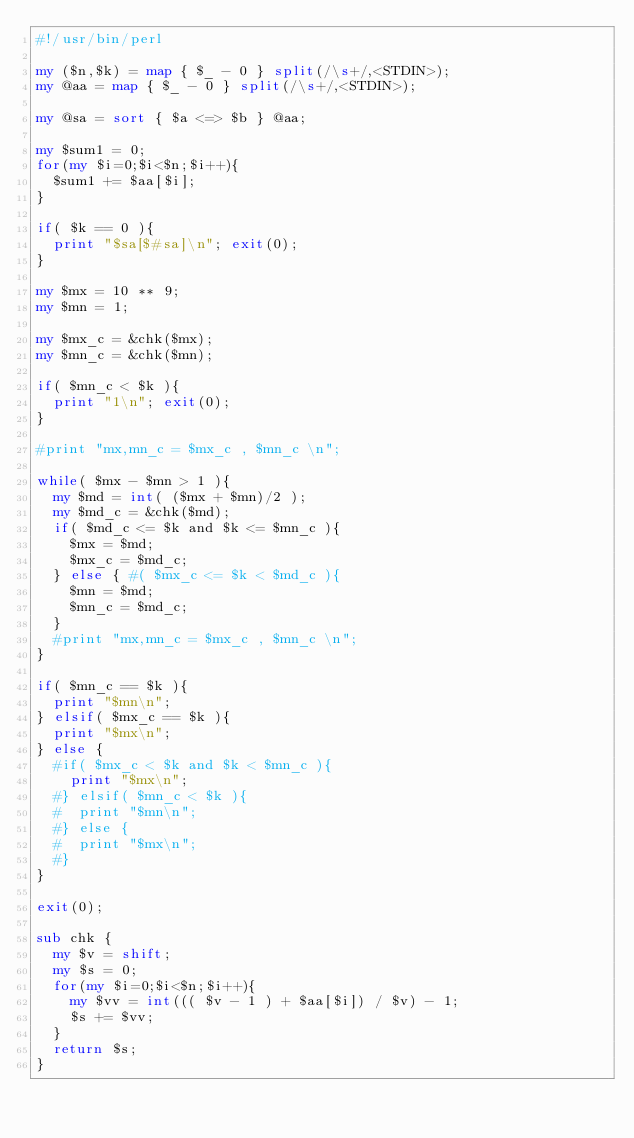<code> <loc_0><loc_0><loc_500><loc_500><_Perl_>#!/usr/bin/perl

my ($n,$k) = map { $_ - 0 } split(/\s+/,<STDIN>);
my @aa = map { $_ - 0 } split(/\s+/,<STDIN>);

my @sa = sort { $a <=> $b } @aa;

my $sum1 = 0;
for(my $i=0;$i<$n;$i++){
  $sum1 += $aa[$i];
}

if( $k == 0 ){
  print "$sa[$#sa]\n"; exit(0);
}

my $mx = 10 ** 9;
my $mn = 1;

my $mx_c = &chk($mx);
my $mn_c = &chk($mn);

if( $mn_c < $k ){
  print "1\n"; exit(0);
}

#print "mx,mn_c = $mx_c , $mn_c \n";

while( $mx - $mn > 1 ){
  my $md = int( ($mx + $mn)/2 );
  my $md_c = &chk($md);
  if( $md_c <= $k and $k <= $mn_c ){
    $mx = $md;
    $mx_c = $md_c;
  } else { #( $mx_c <= $k < $md_c ){
    $mn = $md;
    $mn_c = $md_c;
  }
  #print "mx,mn_c = $mx_c , $mn_c \n";
}

if( $mn_c == $k ){
  print "$mn\n";
} elsif( $mx_c == $k ){
  print "$mx\n";
} else {
  #if( $mx_c < $k and $k < $mn_c ){
    print "$mx\n";
  #} elsif( $mn_c < $k ){
  #  print "$mn\n";
  #} else {
  #  print "$mx\n";
  #}
}

exit(0);

sub chk {
  my $v = shift;
  my $s = 0;
  for(my $i=0;$i<$n;$i++){
    my $vv = int((( $v - 1 ) + $aa[$i]) / $v) - 1;
    $s += $vv;
  }
  return $s;
}
</code> 